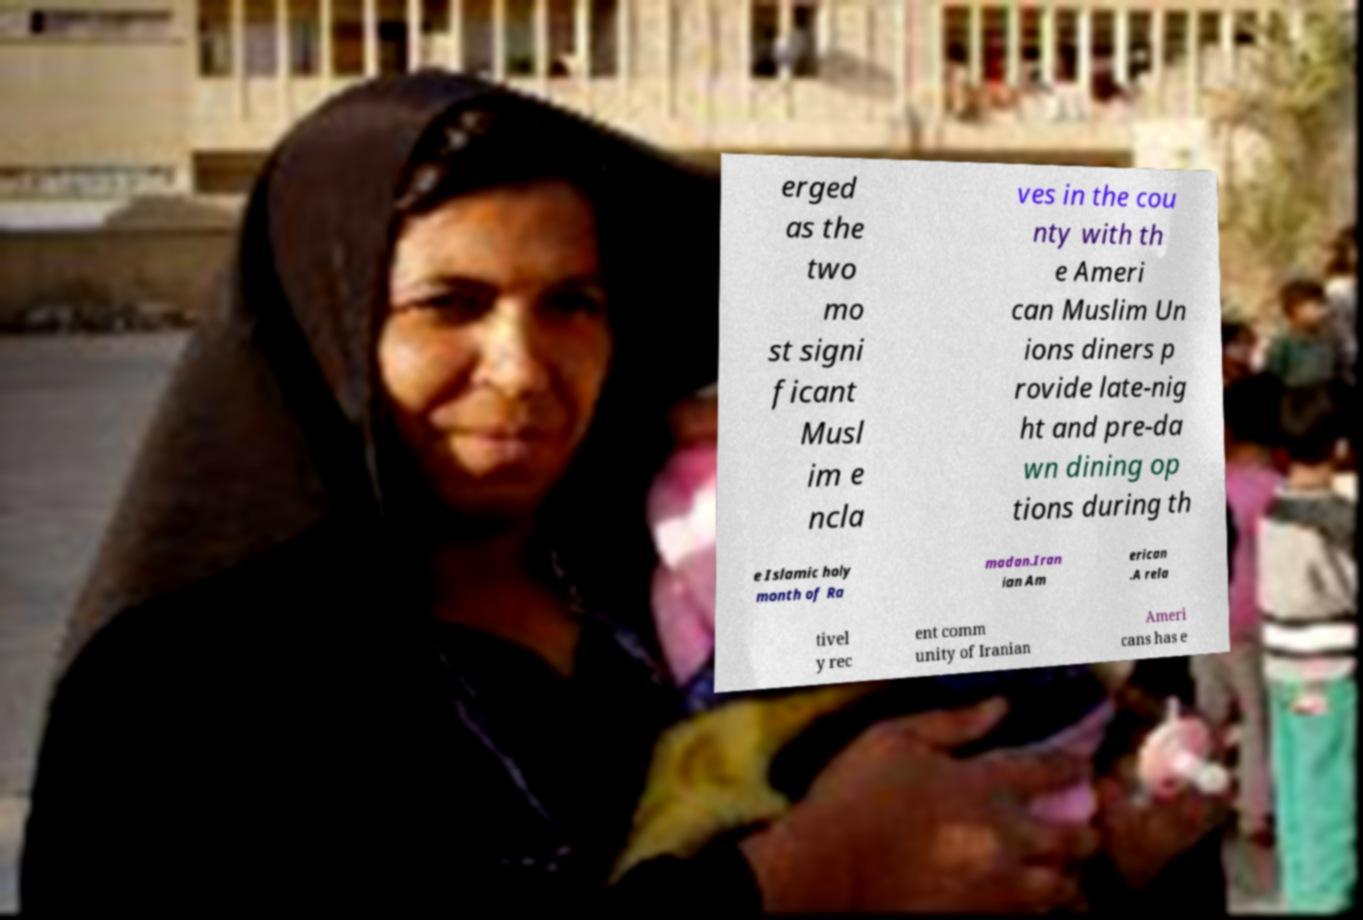What messages or text are displayed in this image? I need them in a readable, typed format. erged as the two mo st signi ficant Musl im e ncla ves in the cou nty with th e Ameri can Muslim Un ions diners p rovide late-nig ht and pre-da wn dining op tions during th e Islamic holy month of Ra madan.Iran ian Am erican .A rela tivel y rec ent comm unity of Iranian Ameri cans has e 